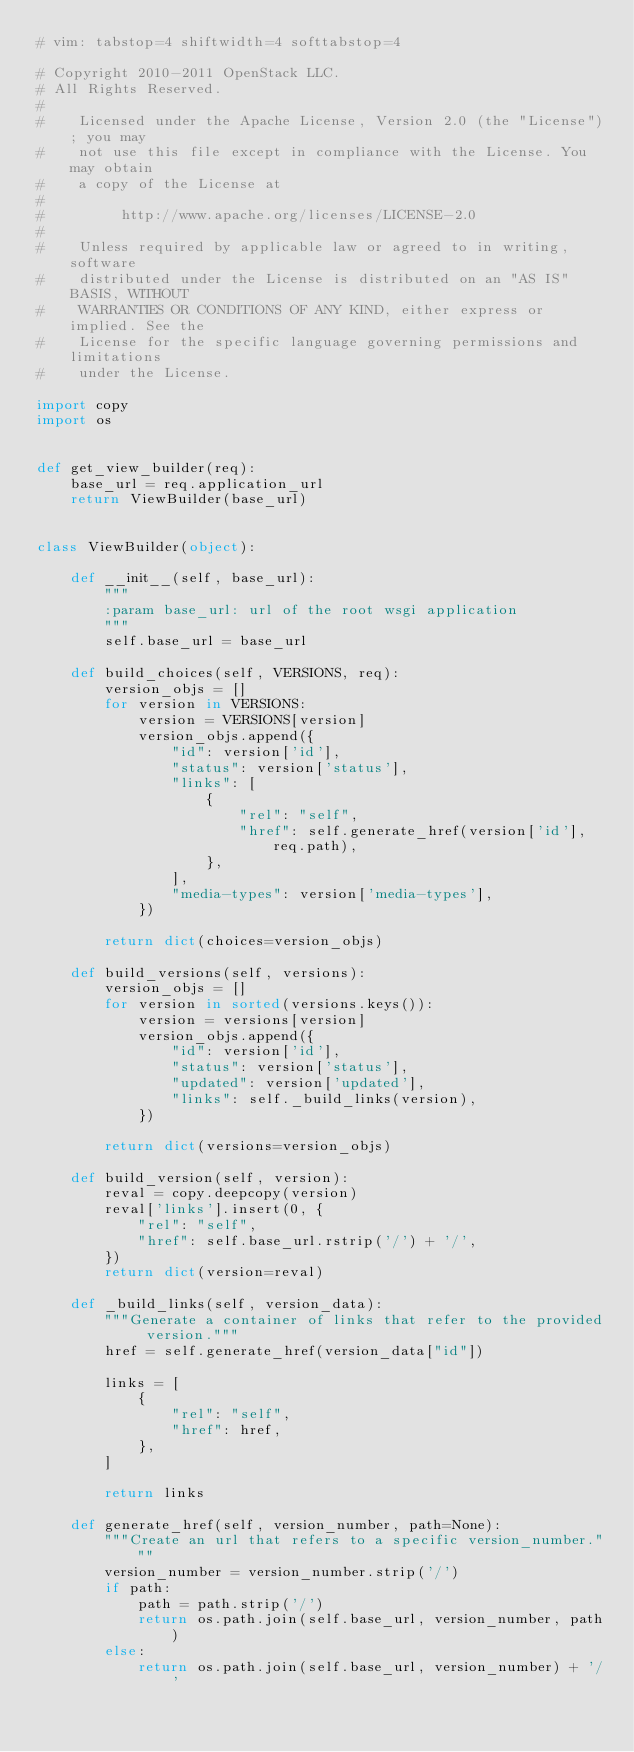<code> <loc_0><loc_0><loc_500><loc_500><_Python_># vim: tabstop=4 shiftwidth=4 softtabstop=4

# Copyright 2010-2011 OpenStack LLC.
# All Rights Reserved.
#
#    Licensed under the Apache License, Version 2.0 (the "License"); you may
#    not use this file except in compliance with the License. You may obtain
#    a copy of the License at
#
#         http://www.apache.org/licenses/LICENSE-2.0
#
#    Unless required by applicable law or agreed to in writing, software
#    distributed under the License is distributed on an "AS IS" BASIS, WITHOUT
#    WARRANTIES OR CONDITIONS OF ANY KIND, either express or implied. See the
#    License for the specific language governing permissions and limitations
#    under the License.

import copy
import os


def get_view_builder(req):
    base_url = req.application_url
    return ViewBuilder(base_url)


class ViewBuilder(object):

    def __init__(self, base_url):
        """
        :param base_url: url of the root wsgi application
        """
        self.base_url = base_url

    def build_choices(self, VERSIONS, req):
        version_objs = []
        for version in VERSIONS:
            version = VERSIONS[version]
            version_objs.append({
                "id": version['id'],
                "status": version['status'],
                "links": [
                    {
                        "rel": "self",
                        "href": self.generate_href(version['id'], req.path),
                    },
                ],
                "media-types": version['media-types'],
            })

        return dict(choices=version_objs)

    def build_versions(self, versions):
        version_objs = []
        for version in sorted(versions.keys()):
            version = versions[version]
            version_objs.append({
                "id": version['id'],
                "status": version['status'],
                "updated": version['updated'],
                "links": self._build_links(version),
            })

        return dict(versions=version_objs)

    def build_version(self, version):
        reval = copy.deepcopy(version)
        reval['links'].insert(0, {
            "rel": "self",
            "href": self.base_url.rstrip('/') + '/',
        })
        return dict(version=reval)

    def _build_links(self, version_data):
        """Generate a container of links that refer to the provided version."""
        href = self.generate_href(version_data["id"])

        links = [
            {
                "rel": "self",
                "href": href,
            },
        ]

        return links

    def generate_href(self, version_number, path=None):
        """Create an url that refers to a specific version_number."""
        version_number = version_number.strip('/')
        if path:
            path = path.strip('/')
            return os.path.join(self.base_url, version_number, path)
        else:
            return os.path.join(self.base_url, version_number) + '/'
</code> 